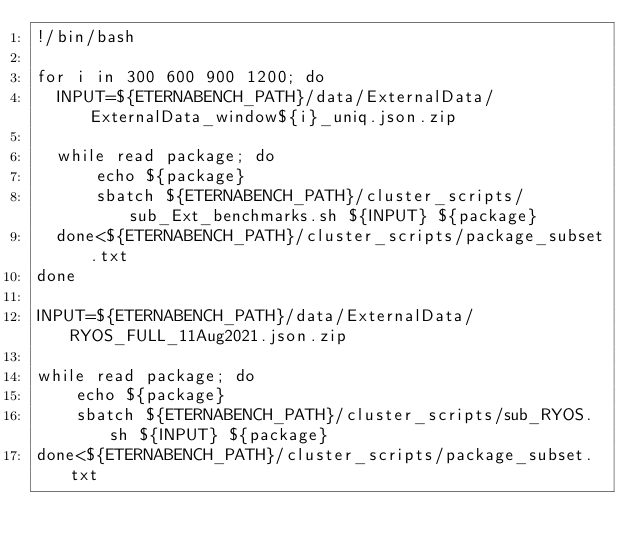<code> <loc_0><loc_0><loc_500><loc_500><_Bash_>!/bin/bash

for i in 300 600 900 1200; do 
	INPUT=${ETERNABENCH_PATH}/data/ExternalData/ExternalData_window${i}_uniq.json.zip

	while read package; do
	    echo ${package}
	    sbatch ${ETERNABENCH_PATH}/cluster_scripts/sub_Ext_benchmarks.sh ${INPUT} ${package}
	done<${ETERNABENCH_PATH}/cluster_scripts/package_subset.txt
done

INPUT=${ETERNABENCH_PATH}/data/ExternalData/RYOS_FULL_11Aug2021.json.zip

while read package; do
    echo ${package}
    sbatch ${ETERNABENCH_PATH}/cluster_scripts/sub_RYOS.sh ${INPUT} ${package}
done<${ETERNABENCH_PATH}/cluster_scripts/package_subset.txt
</code> 